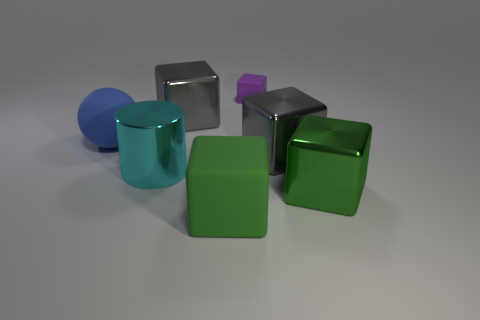Subtract all large metal cubes. How many cubes are left? 2 Add 2 spheres. How many objects exist? 9 Subtract all gray cubes. How many cubes are left? 3 Subtract all spheres. How many objects are left? 6 Subtract 1 balls. How many balls are left? 0 Add 6 tiny purple cubes. How many tiny purple cubes are left? 7 Add 3 big spheres. How many big spheres exist? 4 Subtract 0 purple cylinders. How many objects are left? 7 Subtract all brown cubes. Subtract all purple spheres. How many cubes are left? 5 Subtract all purple spheres. How many green cubes are left? 2 